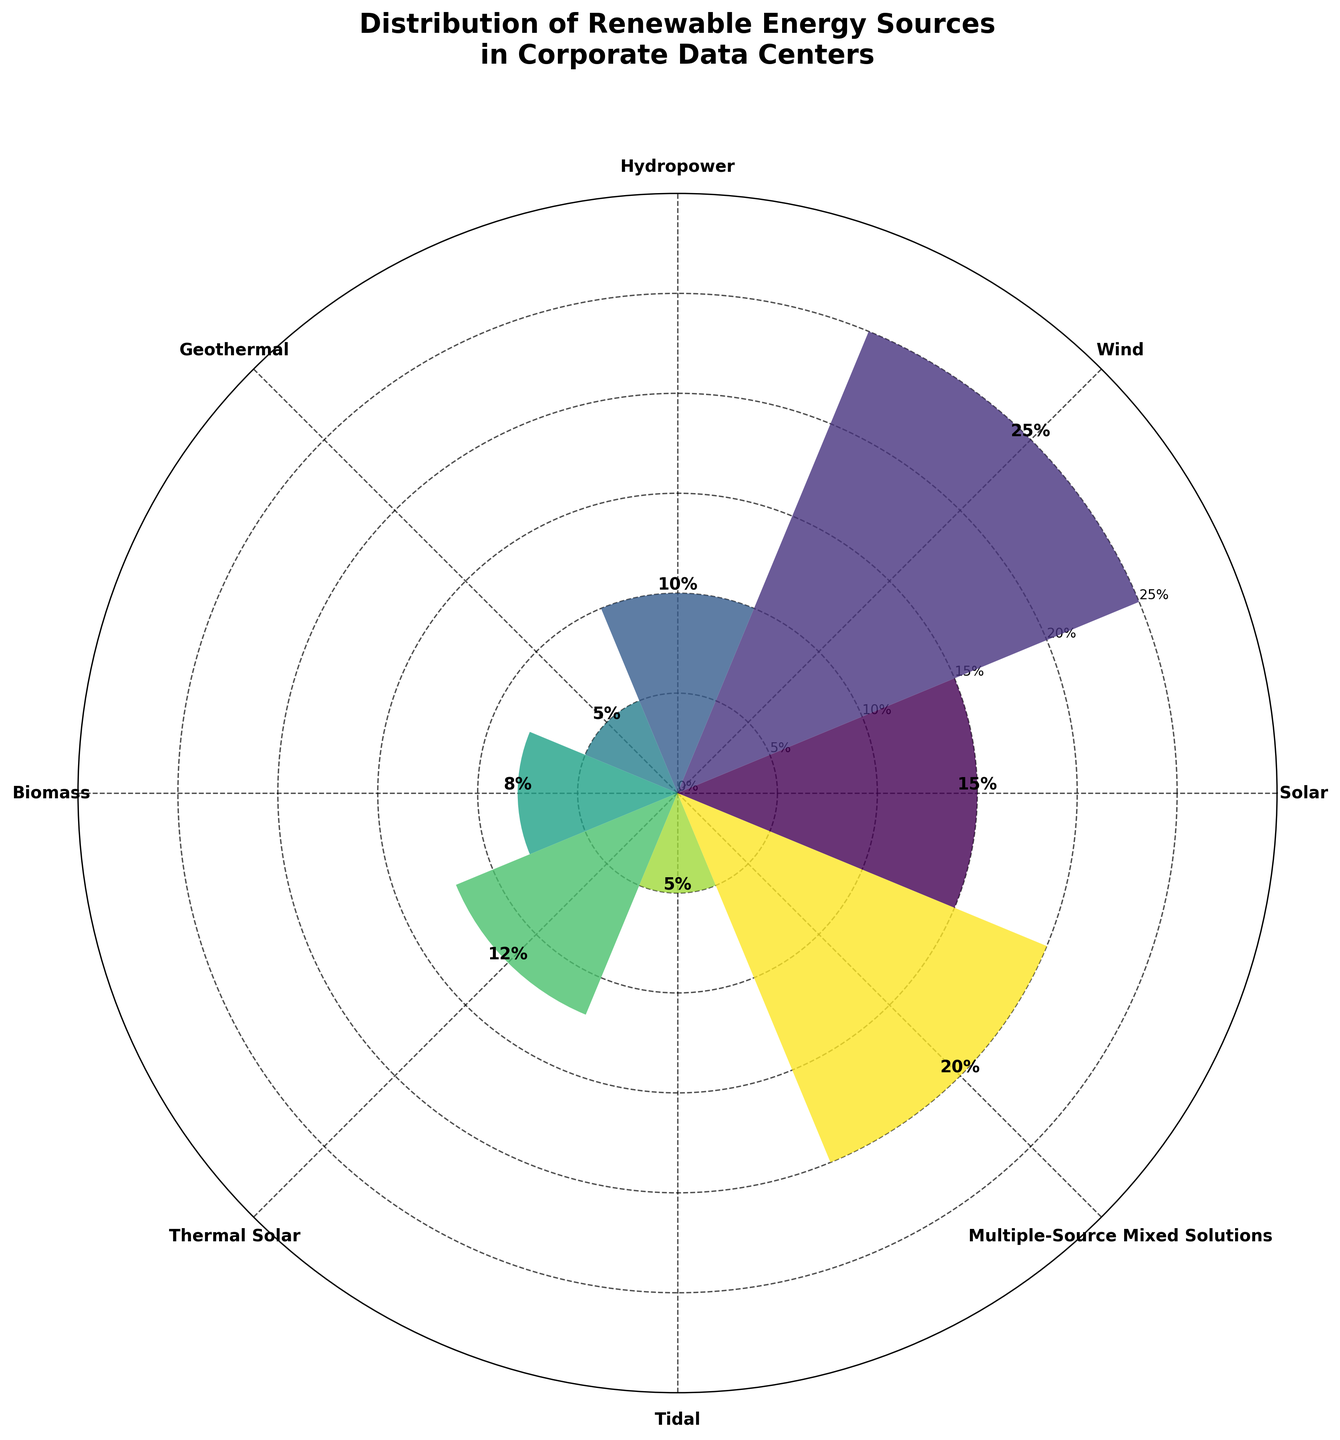What's the total percentage of all renewable energy sources used in corporate data centers? To find the total percentage, sum up the percentages of all renewable energy sources: 15% (Solar) + 25% (Wind) + 10% (Hydropower) + 5% (Geothermal) + 8% (Biomass) + 12% (Thermal Solar) + 5% (Tidal) + 20% (Multiple-Source Mixed Solutions) = 100%.
Answer: 100% Which renewable energy source has the highest integration in corporate data centers? Examine the bars in the rose chart to find the energy source with the largest percentage. The tallest bar represents Wind at 25%.
Answer: Wind What is the difference in the percentage between Wind and Solar energy? Determine the percentage values for Wind (25%) and Solar (15%) from the figure. Subtract the smaller value from the larger value: 25% - 15% = 10%.
Answer: 10% Which two energy sources have the same percentage in corporate data centers? Look at the heights of the bars in the rose chart. Geothermal and Tidal both have the same percentage value of 5%.
Answer: Geothermal and Tidal How much greater is the percentage of Multiple-Source Mixed Solutions compared to Biomass? Check the values for Multiple-Source Mixed Solutions (20%) and Biomass (8%). Subtract Biomass’s percentage from Multiple-Source Mixed Solutions’ percentage: 20% - 8% = 12%.
Answer: 12% Which energy source contributes the least to the corporate data centers? Identify the smallest bar in the rose chart, which represents the energy source with the lowest percentage. Both Geothermal and Tidal have the smallest bars, each with 5%.
Answer: Geothermal and Tidal What is the average percentage of Solar and Thermal Solar energy combined? First, find the individual percentages: Solar (15%) and Thermal Solar (12%). Sum these values and divide by 2 to find the average: (15% + 12%) / 2 = 13.5%.
Answer: 13.5% What is the title of the rose chart? The title of the rose chart is displayed at the top and reads: "Distribution of Renewable Energy Sources in Corporate Data Centers."
Answer: Distribution of Renewable Energy Sources in Corporate Data Centers How many renewable energy sources are represented in the chart? Count the number of distinct bars or categories labeled around the rose chart. There are 8 different sources.
Answer: 8 Which energy source is the second most integrated after Wind? The bar representing the second highest percentage is for Multiple-Source Mixed Solutions, which is 20%.
Answer: Multiple-Source Mixed Solutions 